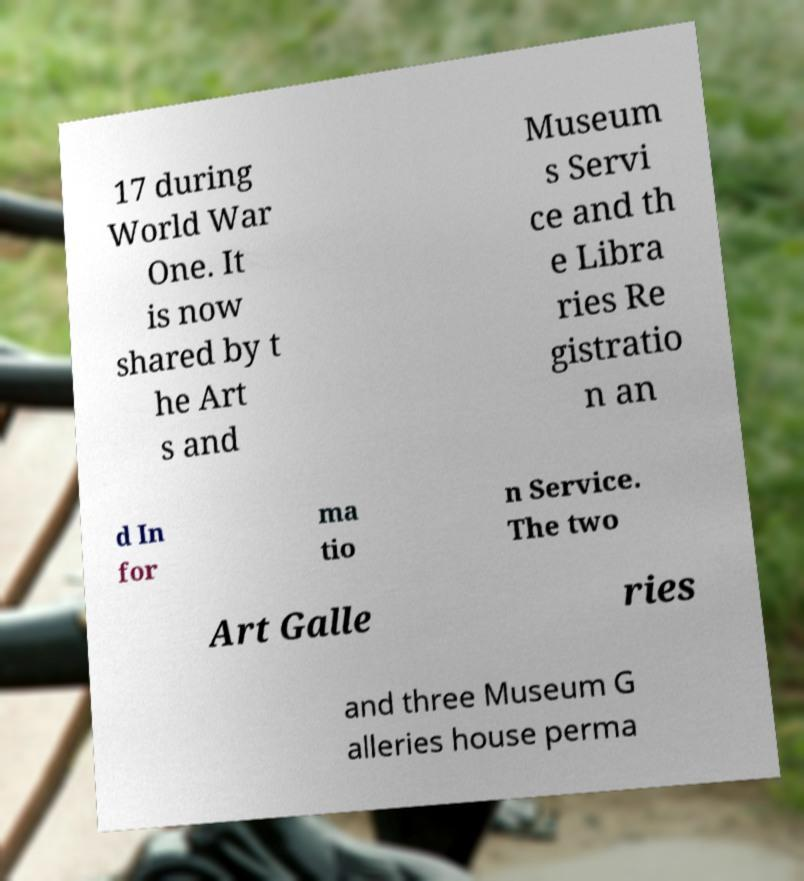There's text embedded in this image that I need extracted. Can you transcribe it verbatim? 17 during World War One. It is now shared by t he Art s and Museum s Servi ce and th e Libra ries Re gistratio n an d In for ma tio n Service. The two Art Galle ries and three Museum G alleries house perma 